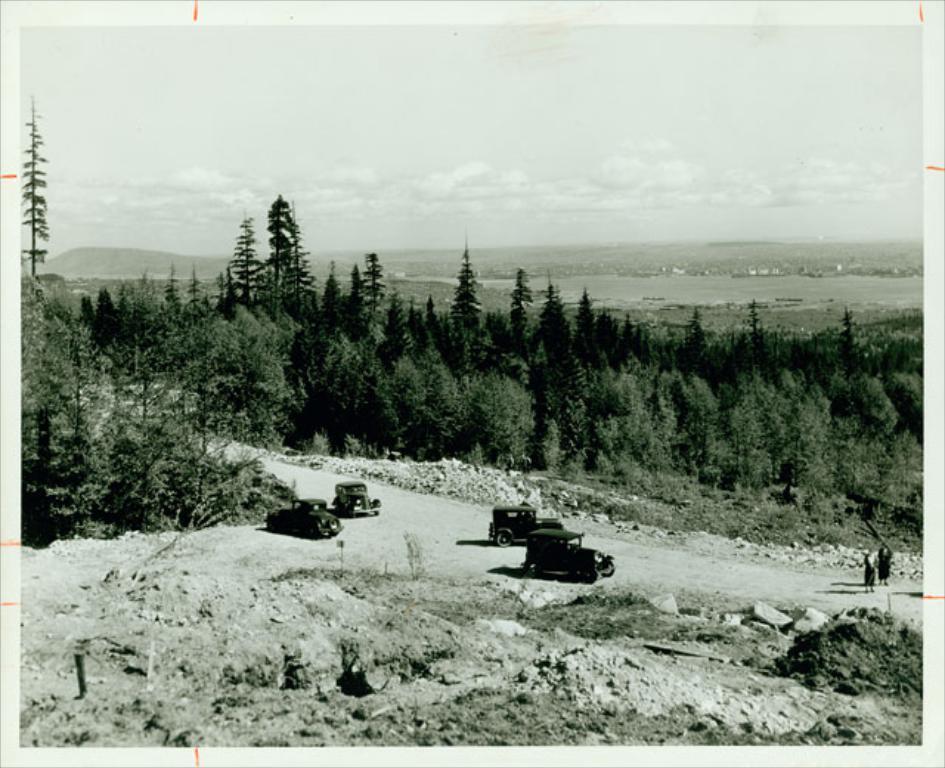In one or two sentences, can you explain what this image depicts? This picture shows few cars and we see trees and we see people and we see a cloudy sky. 